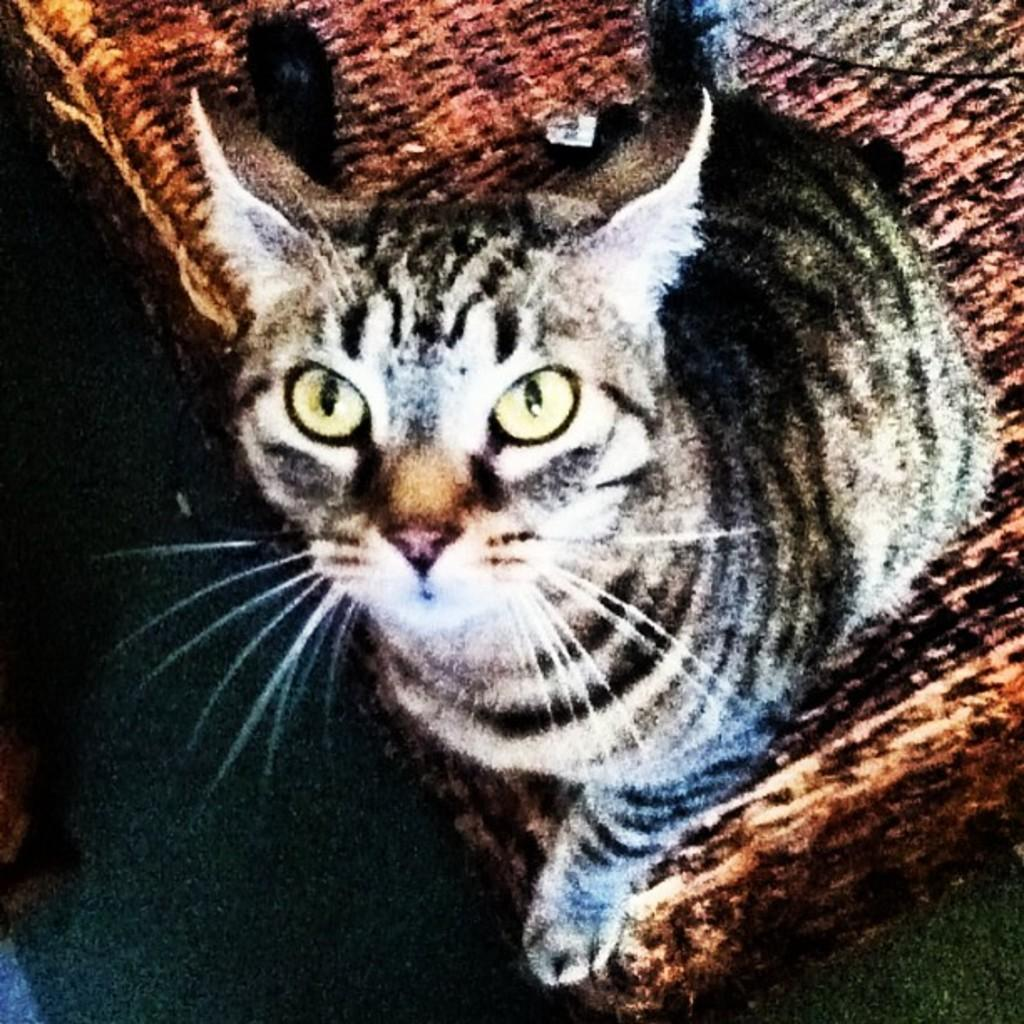What type of animal is in the image? There is a cat in the image. Where is the cat located? The cat is on a wooden table. What type of basin is the cat using in the image? There is no basin present in the image; the cat is on a wooden table. What type of apparel is the cat wearing in the image? Cats do not wear apparel, and there is no clothing visible on the cat in the image. 